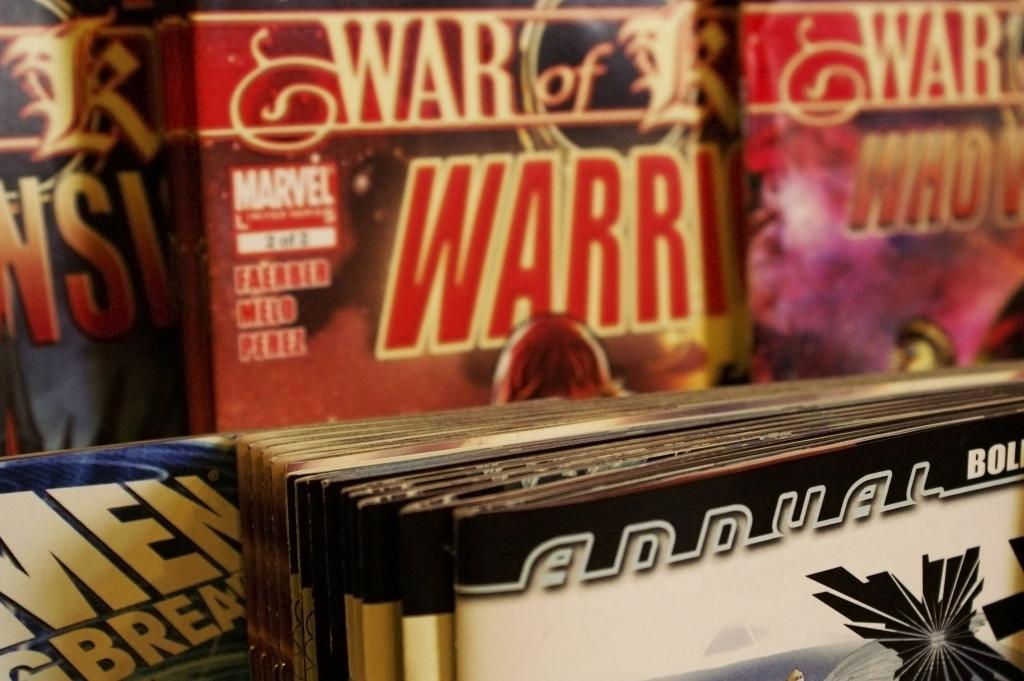<image>
Create a compact narrative representing the image presented. A row of Marvel comic books on a shelf. 